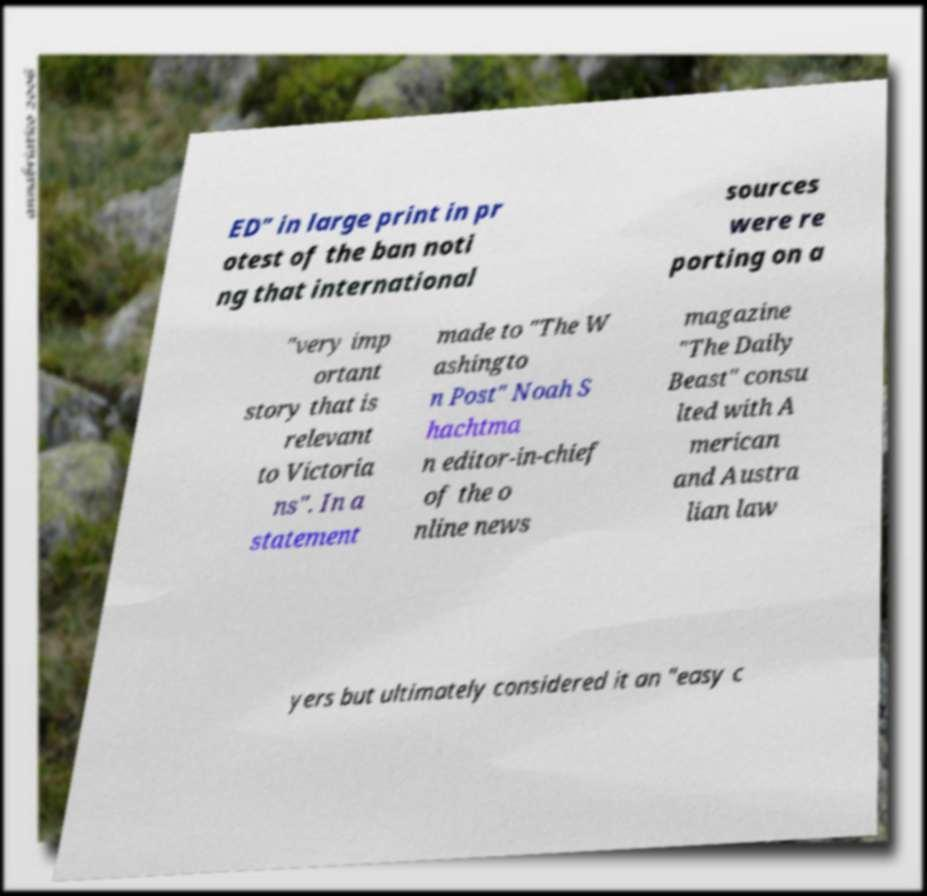What messages or text are displayed in this image? I need them in a readable, typed format. ED" in large print in pr otest of the ban noti ng that international sources were re porting on a "very imp ortant story that is relevant to Victoria ns". In a statement made to "The W ashingto n Post" Noah S hachtma n editor-in-chief of the o nline news magazine "The Daily Beast" consu lted with A merican and Austra lian law yers but ultimately considered it an "easy c 